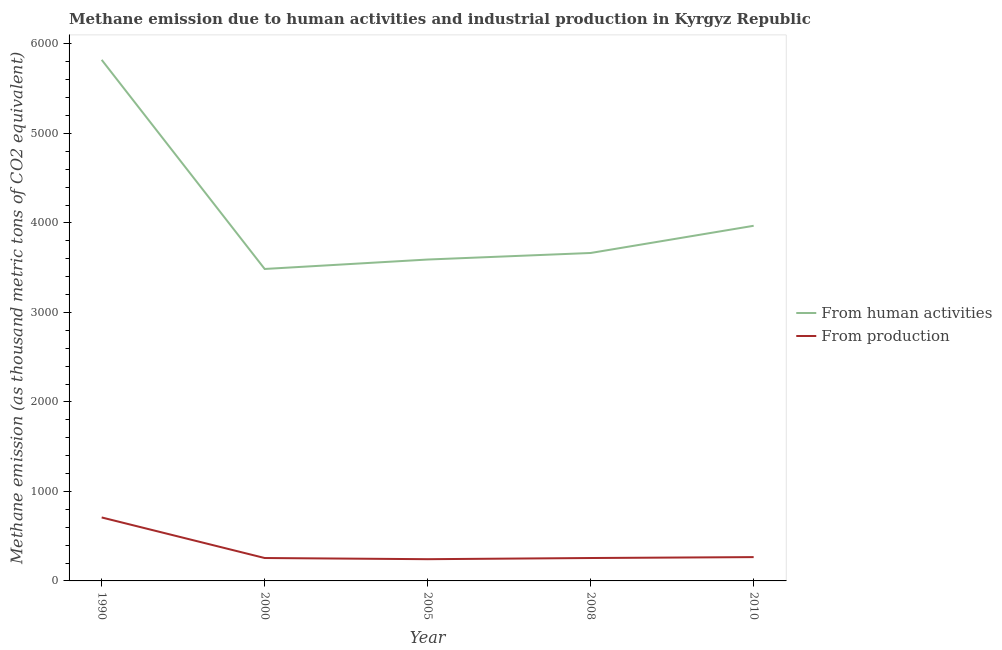How many different coloured lines are there?
Provide a succinct answer. 2. What is the amount of emissions from human activities in 2000?
Make the answer very short. 3485.8. Across all years, what is the maximum amount of emissions generated from industries?
Offer a terse response. 709.3. Across all years, what is the minimum amount of emissions generated from industries?
Keep it short and to the point. 242.8. What is the total amount of emissions from human activities in the graph?
Your response must be concise. 2.05e+04. What is the difference between the amount of emissions from human activities in 2000 and that in 2010?
Provide a succinct answer. -482.6. What is the difference between the amount of emissions from human activities in 2000 and the amount of emissions generated from industries in 2010?
Keep it short and to the point. 3219.8. What is the average amount of emissions from human activities per year?
Provide a succinct answer. 4106.52. In the year 1990, what is the difference between the amount of emissions generated from industries and amount of emissions from human activities?
Provide a short and direct response. -5113.3. What is the ratio of the amount of emissions generated from industries in 2000 to that in 2005?
Offer a terse response. 1.05. Is the amount of emissions generated from industries in 1990 less than that in 2010?
Ensure brevity in your answer.  No. Is the difference between the amount of emissions from human activities in 2005 and 2008 greater than the difference between the amount of emissions generated from industries in 2005 and 2008?
Ensure brevity in your answer.  No. What is the difference between the highest and the second highest amount of emissions from human activities?
Ensure brevity in your answer.  1854.2. What is the difference between the highest and the lowest amount of emissions generated from industries?
Keep it short and to the point. 466.5. In how many years, is the amount of emissions generated from industries greater than the average amount of emissions generated from industries taken over all years?
Keep it short and to the point. 1. Is the sum of the amount of emissions generated from industries in 1990 and 2005 greater than the maximum amount of emissions from human activities across all years?
Your answer should be compact. No. Is the amount of emissions from human activities strictly greater than the amount of emissions generated from industries over the years?
Your response must be concise. Yes. Is the amount of emissions generated from industries strictly less than the amount of emissions from human activities over the years?
Offer a very short reply. Yes. Does the graph contain any zero values?
Ensure brevity in your answer.  No. Where does the legend appear in the graph?
Your answer should be compact. Center right. What is the title of the graph?
Your answer should be very brief. Methane emission due to human activities and industrial production in Kyrgyz Republic. What is the label or title of the X-axis?
Provide a short and direct response. Year. What is the label or title of the Y-axis?
Keep it short and to the point. Methane emission (as thousand metric tons of CO2 equivalent). What is the Methane emission (as thousand metric tons of CO2 equivalent) of From human activities in 1990?
Provide a short and direct response. 5822.6. What is the Methane emission (as thousand metric tons of CO2 equivalent) of From production in 1990?
Keep it short and to the point. 709.3. What is the Methane emission (as thousand metric tons of CO2 equivalent) of From human activities in 2000?
Give a very brief answer. 3485.8. What is the Methane emission (as thousand metric tons of CO2 equivalent) in From production in 2000?
Provide a short and direct response. 255.9. What is the Methane emission (as thousand metric tons of CO2 equivalent) of From human activities in 2005?
Keep it short and to the point. 3591.3. What is the Methane emission (as thousand metric tons of CO2 equivalent) of From production in 2005?
Make the answer very short. 242.8. What is the Methane emission (as thousand metric tons of CO2 equivalent) of From human activities in 2008?
Provide a short and direct response. 3664.5. What is the Methane emission (as thousand metric tons of CO2 equivalent) in From production in 2008?
Give a very brief answer. 256. What is the Methane emission (as thousand metric tons of CO2 equivalent) in From human activities in 2010?
Give a very brief answer. 3968.4. What is the Methane emission (as thousand metric tons of CO2 equivalent) of From production in 2010?
Your response must be concise. 266. Across all years, what is the maximum Methane emission (as thousand metric tons of CO2 equivalent) in From human activities?
Your response must be concise. 5822.6. Across all years, what is the maximum Methane emission (as thousand metric tons of CO2 equivalent) of From production?
Provide a short and direct response. 709.3. Across all years, what is the minimum Methane emission (as thousand metric tons of CO2 equivalent) of From human activities?
Give a very brief answer. 3485.8. Across all years, what is the minimum Methane emission (as thousand metric tons of CO2 equivalent) of From production?
Your answer should be very brief. 242.8. What is the total Methane emission (as thousand metric tons of CO2 equivalent) of From human activities in the graph?
Your answer should be compact. 2.05e+04. What is the total Methane emission (as thousand metric tons of CO2 equivalent) in From production in the graph?
Your response must be concise. 1730. What is the difference between the Methane emission (as thousand metric tons of CO2 equivalent) of From human activities in 1990 and that in 2000?
Give a very brief answer. 2336.8. What is the difference between the Methane emission (as thousand metric tons of CO2 equivalent) in From production in 1990 and that in 2000?
Provide a short and direct response. 453.4. What is the difference between the Methane emission (as thousand metric tons of CO2 equivalent) in From human activities in 1990 and that in 2005?
Your answer should be very brief. 2231.3. What is the difference between the Methane emission (as thousand metric tons of CO2 equivalent) in From production in 1990 and that in 2005?
Your answer should be compact. 466.5. What is the difference between the Methane emission (as thousand metric tons of CO2 equivalent) of From human activities in 1990 and that in 2008?
Offer a terse response. 2158.1. What is the difference between the Methane emission (as thousand metric tons of CO2 equivalent) of From production in 1990 and that in 2008?
Give a very brief answer. 453.3. What is the difference between the Methane emission (as thousand metric tons of CO2 equivalent) in From human activities in 1990 and that in 2010?
Offer a terse response. 1854.2. What is the difference between the Methane emission (as thousand metric tons of CO2 equivalent) of From production in 1990 and that in 2010?
Offer a very short reply. 443.3. What is the difference between the Methane emission (as thousand metric tons of CO2 equivalent) of From human activities in 2000 and that in 2005?
Provide a succinct answer. -105.5. What is the difference between the Methane emission (as thousand metric tons of CO2 equivalent) of From production in 2000 and that in 2005?
Your answer should be very brief. 13.1. What is the difference between the Methane emission (as thousand metric tons of CO2 equivalent) in From human activities in 2000 and that in 2008?
Your answer should be very brief. -178.7. What is the difference between the Methane emission (as thousand metric tons of CO2 equivalent) in From production in 2000 and that in 2008?
Your answer should be very brief. -0.1. What is the difference between the Methane emission (as thousand metric tons of CO2 equivalent) in From human activities in 2000 and that in 2010?
Provide a short and direct response. -482.6. What is the difference between the Methane emission (as thousand metric tons of CO2 equivalent) of From production in 2000 and that in 2010?
Provide a succinct answer. -10.1. What is the difference between the Methane emission (as thousand metric tons of CO2 equivalent) in From human activities in 2005 and that in 2008?
Offer a very short reply. -73.2. What is the difference between the Methane emission (as thousand metric tons of CO2 equivalent) of From human activities in 2005 and that in 2010?
Give a very brief answer. -377.1. What is the difference between the Methane emission (as thousand metric tons of CO2 equivalent) in From production in 2005 and that in 2010?
Give a very brief answer. -23.2. What is the difference between the Methane emission (as thousand metric tons of CO2 equivalent) in From human activities in 2008 and that in 2010?
Offer a very short reply. -303.9. What is the difference between the Methane emission (as thousand metric tons of CO2 equivalent) of From production in 2008 and that in 2010?
Provide a short and direct response. -10. What is the difference between the Methane emission (as thousand metric tons of CO2 equivalent) in From human activities in 1990 and the Methane emission (as thousand metric tons of CO2 equivalent) in From production in 2000?
Keep it short and to the point. 5566.7. What is the difference between the Methane emission (as thousand metric tons of CO2 equivalent) in From human activities in 1990 and the Methane emission (as thousand metric tons of CO2 equivalent) in From production in 2005?
Your answer should be compact. 5579.8. What is the difference between the Methane emission (as thousand metric tons of CO2 equivalent) in From human activities in 1990 and the Methane emission (as thousand metric tons of CO2 equivalent) in From production in 2008?
Make the answer very short. 5566.6. What is the difference between the Methane emission (as thousand metric tons of CO2 equivalent) in From human activities in 1990 and the Methane emission (as thousand metric tons of CO2 equivalent) in From production in 2010?
Provide a short and direct response. 5556.6. What is the difference between the Methane emission (as thousand metric tons of CO2 equivalent) of From human activities in 2000 and the Methane emission (as thousand metric tons of CO2 equivalent) of From production in 2005?
Give a very brief answer. 3243. What is the difference between the Methane emission (as thousand metric tons of CO2 equivalent) in From human activities in 2000 and the Methane emission (as thousand metric tons of CO2 equivalent) in From production in 2008?
Your answer should be compact. 3229.8. What is the difference between the Methane emission (as thousand metric tons of CO2 equivalent) of From human activities in 2000 and the Methane emission (as thousand metric tons of CO2 equivalent) of From production in 2010?
Offer a very short reply. 3219.8. What is the difference between the Methane emission (as thousand metric tons of CO2 equivalent) of From human activities in 2005 and the Methane emission (as thousand metric tons of CO2 equivalent) of From production in 2008?
Provide a short and direct response. 3335.3. What is the difference between the Methane emission (as thousand metric tons of CO2 equivalent) of From human activities in 2005 and the Methane emission (as thousand metric tons of CO2 equivalent) of From production in 2010?
Provide a short and direct response. 3325.3. What is the difference between the Methane emission (as thousand metric tons of CO2 equivalent) of From human activities in 2008 and the Methane emission (as thousand metric tons of CO2 equivalent) of From production in 2010?
Provide a short and direct response. 3398.5. What is the average Methane emission (as thousand metric tons of CO2 equivalent) in From human activities per year?
Offer a very short reply. 4106.52. What is the average Methane emission (as thousand metric tons of CO2 equivalent) in From production per year?
Keep it short and to the point. 346. In the year 1990, what is the difference between the Methane emission (as thousand metric tons of CO2 equivalent) of From human activities and Methane emission (as thousand metric tons of CO2 equivalent) of From production?
Your response must be concise. 5113.3. In the year 2000, what is the difference between the Methane emission (as thousand metric tons of CO2 equivalent) of From human activities and Methane emission (as thousand metric tons of CO2 equivalent) of From production?
Offer a very short reply. 3229.9. In the year 2005, what is the difference between the Methane emission (as thousand metric tons of CO2 equivalent) of From human activities and Methane emission (as thousand metric tons of CO2 equivalent) of From production?
Offer a very short reply. 3348.5. In the year 2008, what is the difference between the Methane emission (as thousand metric tons of CO2 equivalent) in From human activities and Methane emission (as thousand metric tons of CO2 equivalent) in From production?
Offer a terse response. 3408.5. In the year 2010, what is the difference between the Methane emission (as thousand metric tons of CO2 equivalent) in From human activities and Methane emission (as thousand metric tons of CO2 equivalent) in From production?
Offer a terse response. 3702.4. What is the ratio of the Methane emission (as thousand metric tons of CO2 equivalent) of From human activities in 1990 to that in 2000?
Your answer should be compact. 1.67. What is the ratio of the Methane emission (as thousand metric tons of CO2 equivalent) in From production in 1990 to that in 2000?
Give a very brief answer. 2.77. What is the ratio of the Methane emission (as thousand metric tons of CO2 equivalent) of From human activities in 1990 to that in 2005?
Ensure brevity in your answer.  1.62. What is the ratio of the Methane emission (as thousand metric tons of CO2 equivalent) in From production in 1990 to that in 2005?
Your answer should be compact. 2.92. What is the ratio of the Methane emission (as thousand metric tons of CO2 equivalent) of From human activities in 1990 to that in 2008?
Your response must be concise. 1.59. What is the ratio of the Methane emission (as thousand metric tons of CO2 equivalent) in From production in 1990 to that in 2008?
Your answer should be very brief. 2.77. What is the ratio of the Methane emission (as thousand metric tons of CO2 equivalent) of From human activities in 1990 to that in 2010?
Your answer should be compact. 1.47. What is the ratio of the Methane emission (as thousand metric tons of CO2 equivalent) of From production in 1990 to that in 2010?
Provide a short and direct response. 2.67. What is the ratio of the Methane emission (as thousand metric tons of CO2 equivalent) of From human activities in 2000 to that in 2005?
Ensure brevity in your answer.  0.97. What is the ratio of the Methane emission (as thousand metric tons of CO2 equivalent) of From production in 2000 to that in 2005?
Your answer should be compact. 1.05. What is the ratio of the Methane emission (as thousand metric tons of CO2 equivalent) in From human activities in 2000 to that in 2008?
Ensure brevity in your answer.  0.95. What is the ratio of the Methane emission (as thousand metric tons of CO2 equivalent) in From production in 2000 to that in 2008?
Offer a terse response. 1. What is the ratio of the Methane emission (as thousand metric tons of CO2 equivalent) of From human activities in 2000 to that in 2010?
Provide a short and direct response. 0.88. What is the ratio of the Methane emission (as thousand metric tons of CO2 equivalent) in From human activities in 2005 to that in 2008?
Provide a short and direct response. 0.98. What is the ratio of the Methane emission (as thousand metric tons of CO2 equivalent) of From production in 2005 to that in 2008?
Offer a very short reply. 0.95. What is the ratio of the Methane emission (as thousand metric tons of CO2 equivalent) in From human activities in 2005 to that in 2010?
Ensure brevity in your answer.  0.91. What is the ratio of the Methane emission (as thousand metric tons of CO2 equivalent) in From production in 2005 to that in 2010?
Offer a terse response. 0.91. What is the ratio of the Methane emission (as thousand metric tons of CO2 equivalent) of From human activities in 2008 to that in 2010?
Ensure brevity in your answer.  0.92. What is the ratio of the Methane emission (as thousand metric tons of CO2 equivalent) of From production in 2008 to that in 2010?
Make the answer very short. 0.96. What is the difference between the highest and the second highest Methane emission (as thousand metric tons of CO2 equivalent) in From human activities?
Make the answer very short. 1854.2. What is the difference between the highest and the second highest Methane emission (as thousand metric tons of CO2 equivalent) in From production?
Offer a terse response. 443.3. What is the difference between the highest and the lowest Methane emission (as thousand metric tons of CO2 equivalent) of From human activities?
Keep it short and to the point. 2336.8. What is the difference between the highest and the lowest Methane emission (as thousand metric tons of CO2 equivalent) of From production?
Your answer should be very brief. 466.5. 